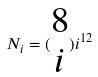<formula> <loc_0><loc_0><loc_500><loc_500>N _ { i } = ( \begin{matrix} 8 \\ i \end{matrix} ) i ^ { 1 2 }</formula> 